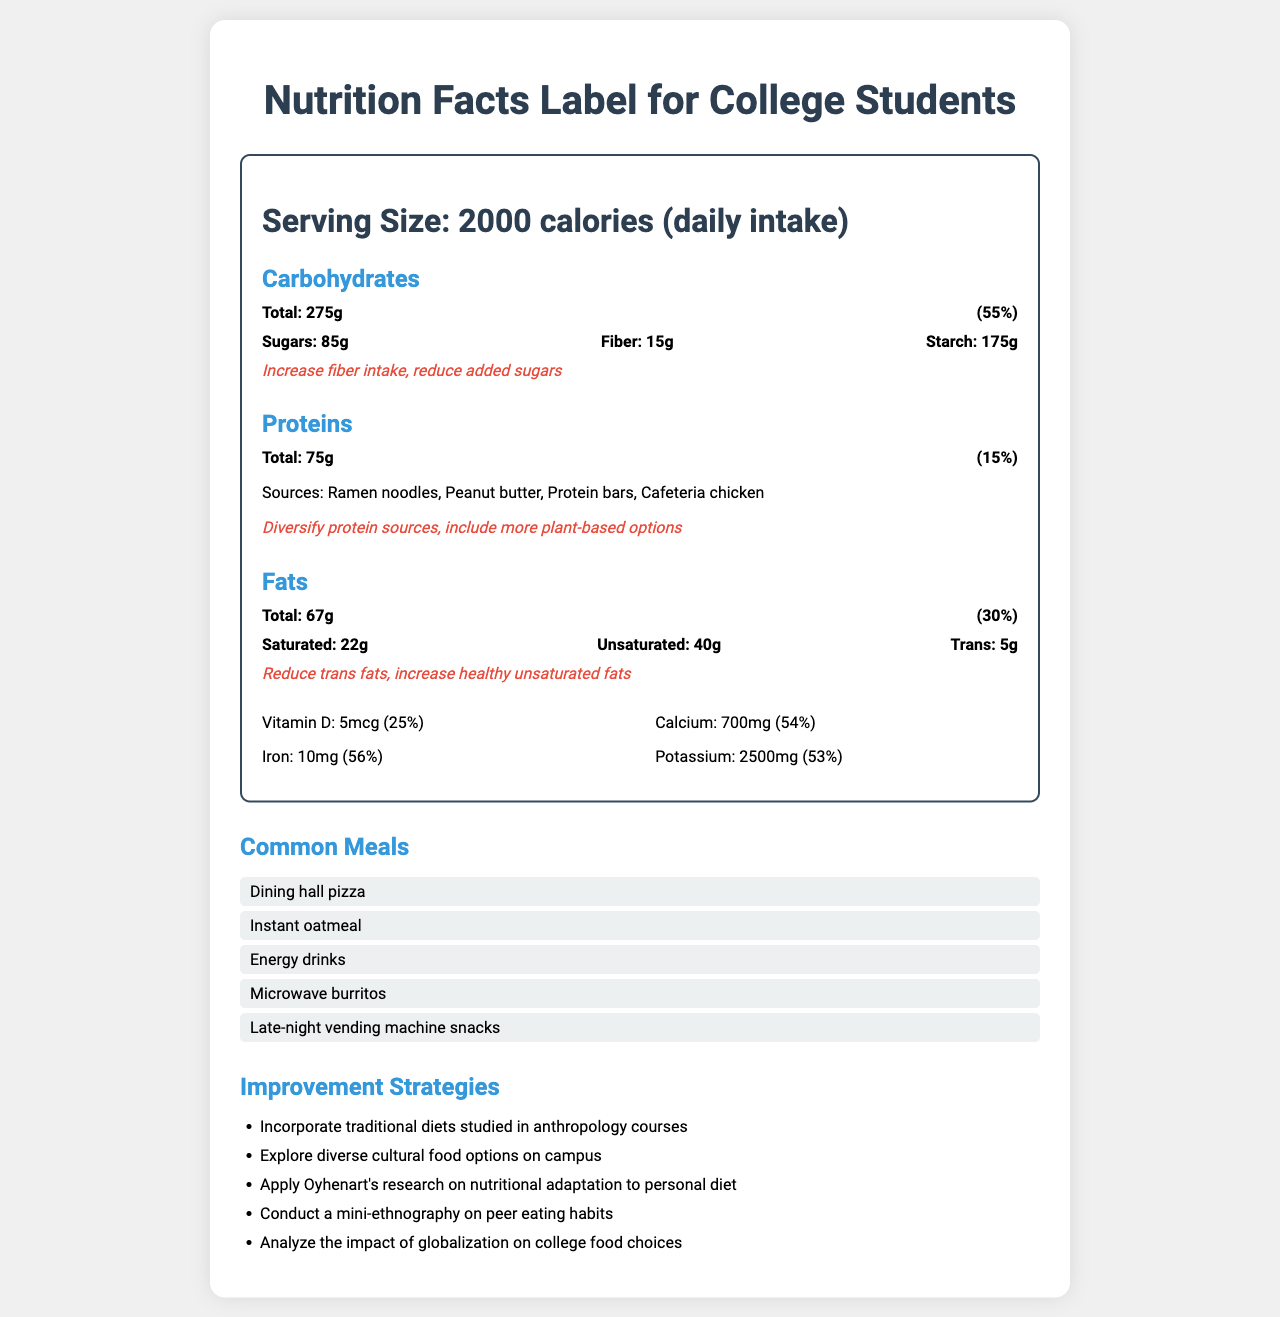what is the serving size? The document specifies "Serving Size: 2000 calories (daily intake)" at the top of the Nutrition Facts Label.
Answer: 2000 calories (daily intake) which macronutrient has the highest daily intake percentage? A. Carbohydrates B. Proteins C. Fats The percentage intake of carbohydrates is 55%, which is higher than proteins (15%) and fats (30%).
Answer: A what are common sources of protein in a college student's diet according to the document? The document lists the sources of protein as "Ramen noodles, Peanut butter, Protein bars, Cafeteria chicken."
Answer: Ramen noodles, Peanut butter, Protein bars, Cafeteria chicken how much fiber should be increased in the diet? The document recommends "Increase fiber intake" but does not specify how much to increase.
Answer: Not specified True or False: The document suggests reducing saturated fats. The document suggests reducing trans fats and increasing healthy unsaturated fats, not reducing saturated fats.
Answer: False how much vitamin D is consumed daily according to the document? The document lists Vitamin D consumption as "Vitamin D: 5 mcg (25%)".
Answer: 5 mcg summarize the main strategies for dietary improvement mentioned in the document. These improvement strategies are listed under "Improvement Strategies" in the final section of the document.
Answer: The document suggests incorporating traditional diets studied in anthropology courses, exploring diverse cultural food options on campus, applying Oyhenart's research on nutritional adaptation to personal diets, conducting a mini-ethnography on peer eating habits, and analyzing the impact of globalization on college food choices. what percentage of daily iron intake is covered? The document states "Iron: 10 mg (56%)" under the micronutrients section.
Answer: 56% which cultural influences affect the dietary choices of college students? A. Fast food culture B. Convenience-driven choices C. Limited cooking facilities in dorms D. All of the above The document lists all these cultural influences as affecting the dietary choices of college students.
Answer: D how many grams of trans fats are consumed daily? The document states "Trans: 5g" under the fats breakdown.
Answer: 5 grams what strategy can a student use to explore the impact of globalization on college food choices? The document suggests both "Conduct a mini-ethnography on peer eating habits" and "Analyze the impact of globalization on college food choices" as strategies for understanding college food choices.
Answer: Conduct a mini-ethnography on peer eating habits which carbohydrate component should be reduced according to the document's recommendations? The document recommends reducing added sugars under the carbohydrates section.
Answer: Added sugars what are the economic factors influencing college students' diets mentioned in the document? The document lists these economic factors as influencing college students' diets.
Answer: Budget constraints, Meal plan limitations, Part-time job schedules which micronutrient has the highest daily intake percentage among those listed? Iron has the highest daily intake percentage at 56%, compared to Vitamin D (25%), Calcium (54%), and Potassium (53%).
Answer: Iron what types of meals do college students commonly consume? The document lists these under "Common Meals."
Answer: Dining hall pizza, Instant oatmeal, Energy drinks, Microwave burritos, Late-night vending machine snacks provide an overall summary of the document. The document merges nutritional data and anthropological insights to highlight current dietary patterns and suggest possible improvements for college students.
Answer: The document provides a nutrition facts label for a typical college student's daily diet, focusing on macronutrients such as carbohydrates, proteins, and fats, and emphasizing areas for improvement. It also includes micronutrient intake, common meals, and anthropological context like cultural influences, economic factors, and nutritional knowledge. Strategies for dietary improvement based on anthropology courses and research are suggested. 